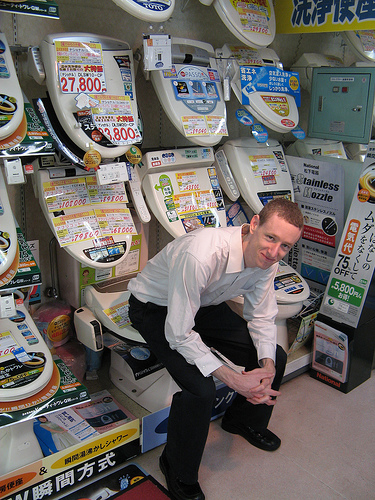Is the boy on a skateboard? No, the boy is not on a skateboard; he's actually sitting on a toilet displayed in the store. 